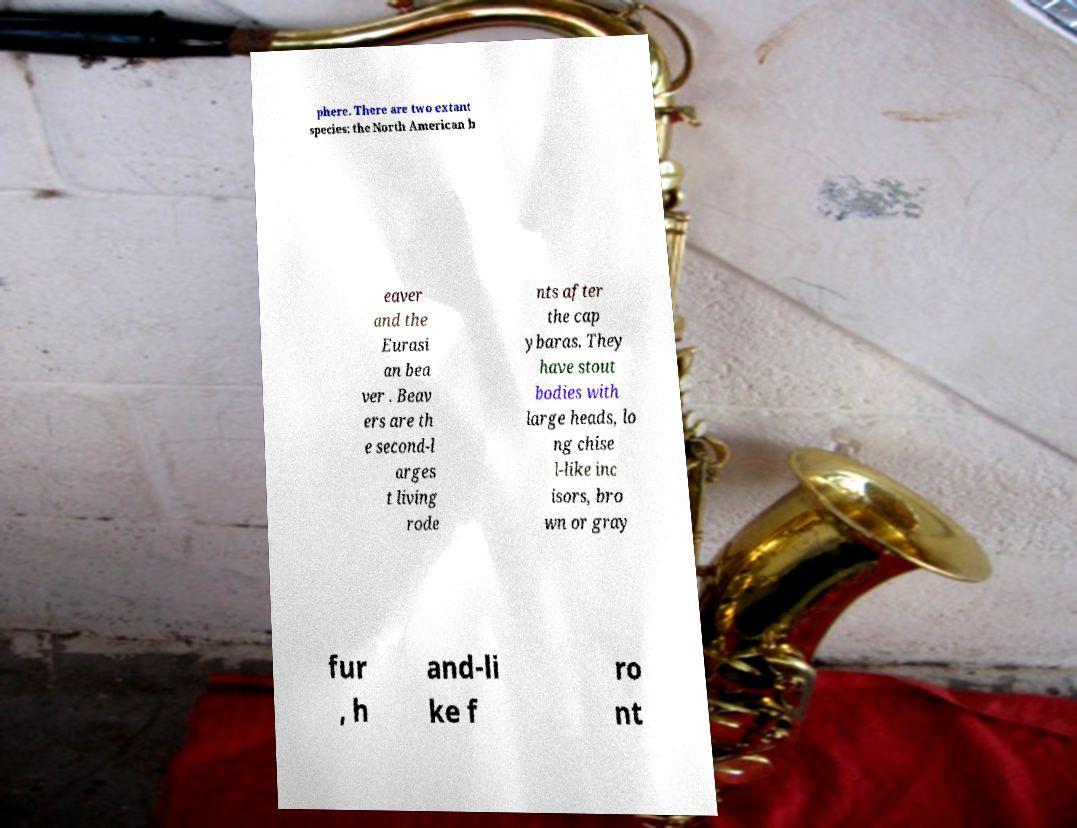There's text embedded in this image that I need extracted. Can you transcribe it verbatim? phere. There are two extant species: the North American b eaver and the Eurasi an bea ver . Beav ers are th e second-l arges t living rode nts after the cap ybaras. They have stout bodies with large heads, lo ng chise l-like inc isors, bro wn or gray fur , h and-li ke f ro nt 